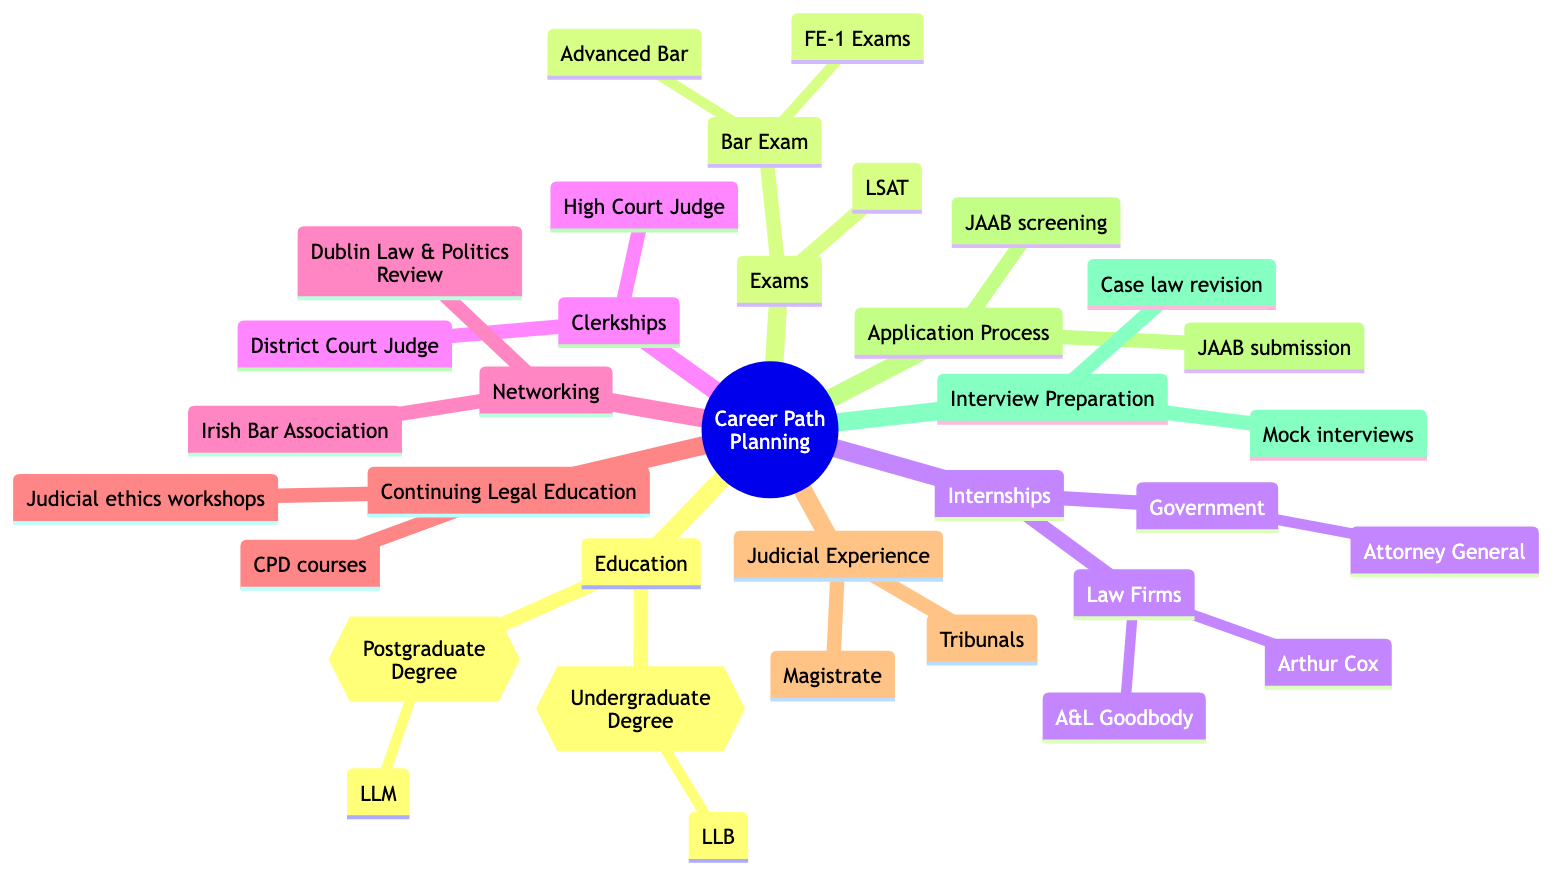What is the undergraduate degree needed? The diagram clearly states that the undergraduate degree is a Bachelor of Laws (LLB), which is listed under the Education section.
Answer: Bachelor of Laws (LLB) What type of clerkship is mentioned under Clerkships? There are two types of clerkships mentioned: Clerkship with a High Court Judge and Clerkship with a District Court Judge, both of which are listed in the Clerkships section.
Answer: High Court Judge How many types of exams are listed? The Exams section lists three specific exam types: LSAT, FE-1 Exams, and Advanced Bar, totaling three types.
Answer: 3 Which organization handles the application submission? The Application Process section explicitly refers to the Judicial Appointments Advisory Board (JAAB) as the organization for filing applications, thus answering the question.
Answer: Judicial Appointments Advisory Board (JAAB) What is one of the networking opportunities listed? According to the Networking section, one of the opportunities for networking is membership in the Irish Bar Association, which is clearly stated.
Answer: Irish Bar Association What two types of judicial experience are described? Within the Judicial Experience section, it specifies serving as a Magistrate in local courts and presiding over administrative tribunals as the two types of experience mentioned.
Answer: Magistrate and Tribunals How many types of continuing legal education are mentioned? The Continuing Legal Education section outlines two types: CPD courses and workshops, leading to the conclusion that there are two types mentioned.
Answer: 2 What is one preparatory method for interviews? Under the Interview Preparation section, it highlights conducting mock interviews with senior lawyers as a specific method for preparation, thus answering the question.
Answer: Mock interviews 